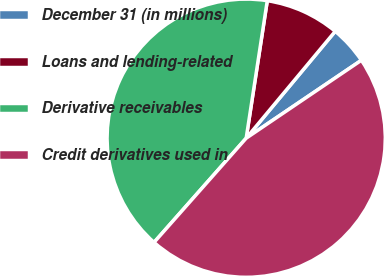Convert chart to OTSL. <chart><loc_0><loc_0><loc_500><loc_500><pie_chart><fcel>December 31 (in millions)<fcel>Loans and lending-related<fcel>Derivative receivables<fcel>Credit derivatives used in<nl><fcel>4.48%<fcel>8.63%<fcel>40.9%<fcel>45.99%<nl></chart> 